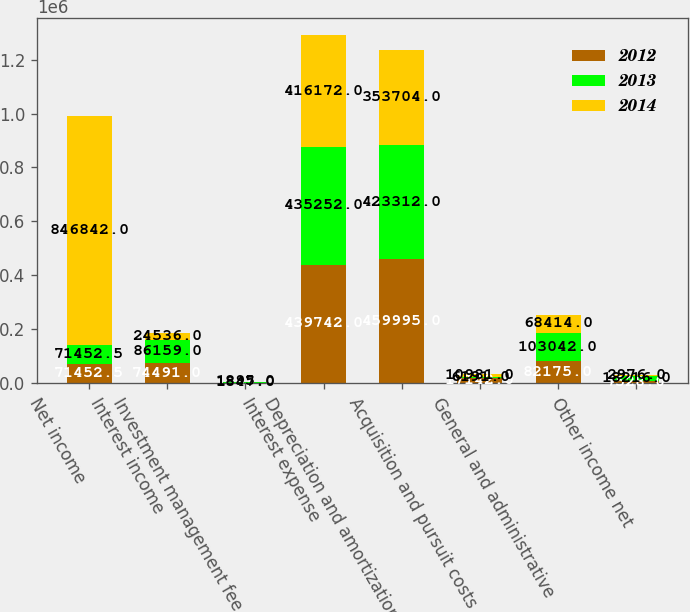Convert chart to OTSL. <chart><loc_0><loc_0><loc_500><loc_500><stacked_bar_chart><ecel><fcel>Net income<fcel>Interest income<fcel>Investment management fee<fcel>Interest expense<fcel>Depreciation and amortization<fcel>Acquisition and pursuit costs<fcel>General and administrative<fcel>Other income net<nl><fcel>2012<fcel>71452.5<fcel>74491<fcel>1809<fcel>439742<fcel>459995<fcel>17142<fcel>82175<fcel>7528<nl><fcel>2013<fcel>71452.5<fcel>86159<fcel>1847<fcel>435252<fcel>423312<fcel>6191<fcel>103042<fcel>18216<nl><fcel>2014<fcel>846842<fcel>24536<fcel>1895<fcel>416172<fcel>353704<fcel>10981<fcel>68414<fcel>2976<nl></chart> 